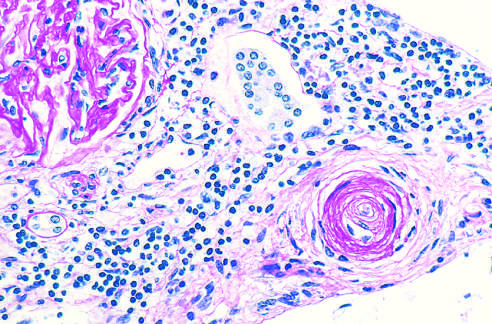what is periodic acid-schiff stain?
Answer the question using a single word or phrase. Luminal obliteration 